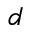Convert formula to latex. <formula><loc_0><loc_0><loc_500><loc_500>d</formula> 